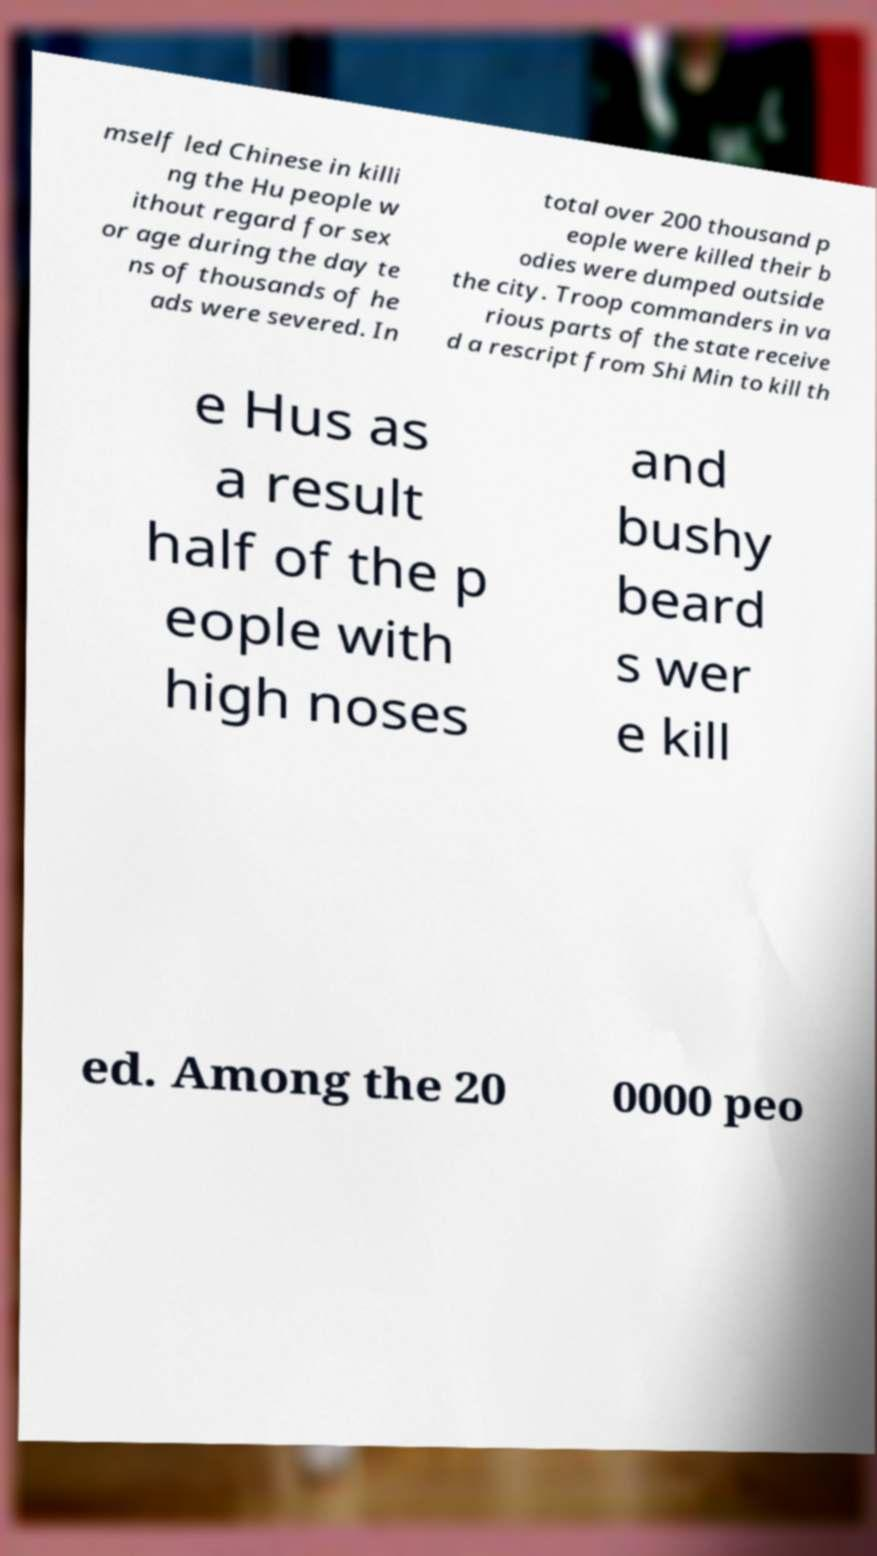What messages or text are displayed in this image? I need them in a readable, typed format. mself led Chinese in killi ng the Hu people w ithout regard for sex or age during the day te ns of thousands of he ads were severed. In total over 200 thousand p eople were killed their b odies were dumped outside the city. Troop commanders in va rious parts of the state receive d a rescript from Shi Min to kill th e Hus as a result half of the p eople with high noses and bushy beard s wer e kill ed. Among the 20 0000 peo 